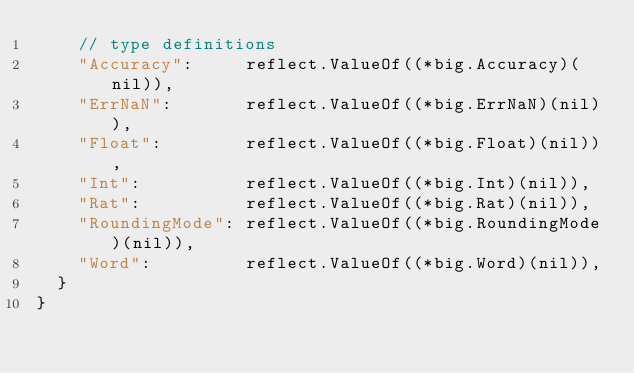<code> <loc_0><loc_0><loc_500><loc_500><_Go_>		// type definitions
		"Accuracy":     reflect.ValueOf((*big.Accuracy)(nil)),
		"ErrNaN":       reflect.ValueOf((*big.ErrNaN)(nil)),
		"Float":        reflect.ValueOf((*big.Float)(nil)),
		"Int":          reflect.ValueOf((*big.Int)(nil)),
		"Rat":          reflect.ValueOf((*big.Rat)(nil)),
		"RoundingMode": reflect.ValueOf((*big.RoundingMode)(nil)),
		"Word":         reflect.ValueOf((*big.Word)(nil)),
	}
}
</code> 